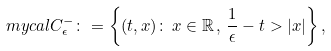<formula> <loc_0><loc_0><loc_500><loc_500>\ m y c a l { C } _ { \epsilon } ^ { - } \colon = \left \{ ( t , x ) \colon \, x \in { \mathbb { R } } \, , \, \frac { 1 } { \epsilon } - t > | x | \right \} ,</formula> 